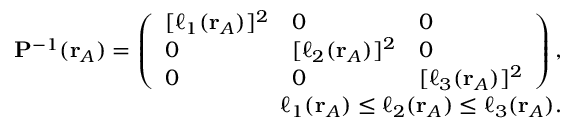<formula> <loc_0><loc_0><loc_500><loc_500>\begin{array} { r } { P ^ { - 1 } ( r _ { A } ) = \left ( \begin{array} { l l l } { [ \ell _ { 1 } ( r _ { A } ) ] ^ { 2 } } & { 0 } & { 0 } \\ { 0 } & { [ \ell _ { 2 } ( r _ { A } ) ] ^ { 2 } } & { 0 } \\ { 0 } & { 0 } & { [ \ell _ { 3 } ( r _ { A } ) ] ^ { 2 } } \end{array} \right ) , } \\ { \ell _ { 1 } ( r _ { A } ) \leq \ell _ { 2 } ( r _ { A } ) \leq \ell _ { 3 } ( r _ { A } ) . } \end{array}</formula> 